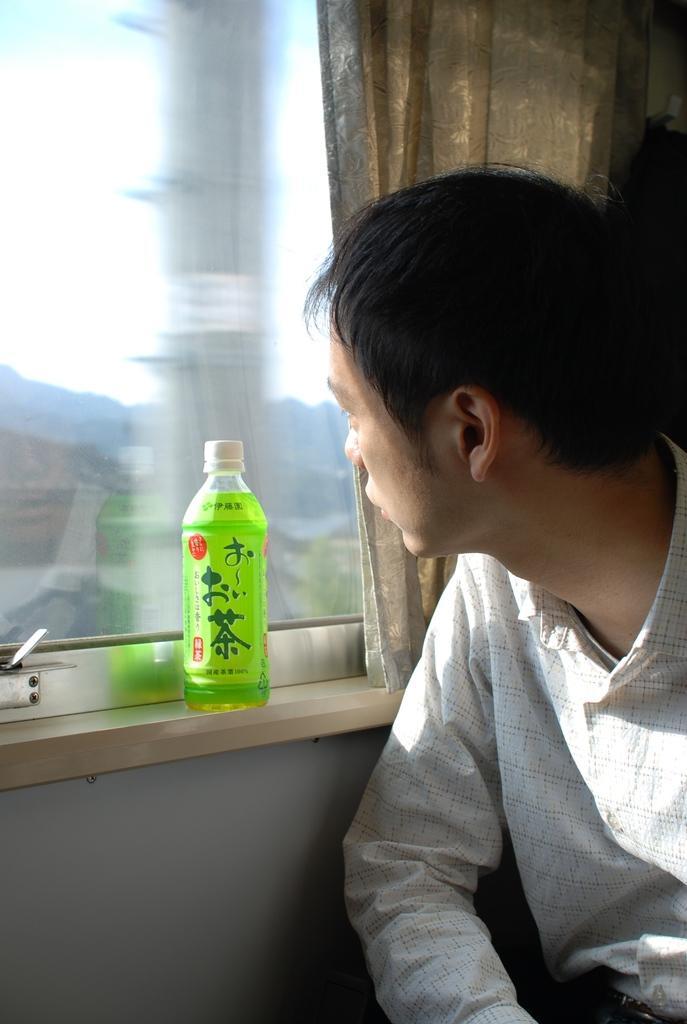In one or two sentences, can you explain what this image depicts? In this picture we can see a man and there is a bottle. This is window and there is a curtain. 